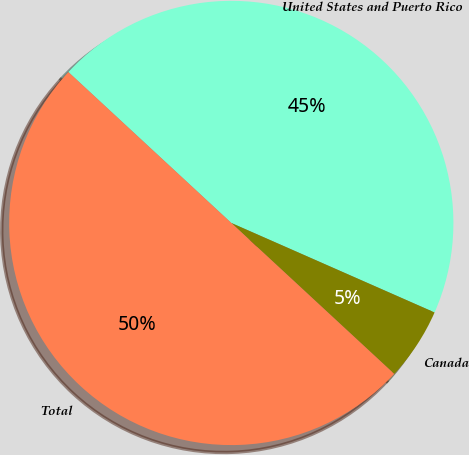Convert chart. <chart><loc_0><loc_0><loc_500><loc_500><pie_chart><fcel>United States and Puerto Rico<fcel>Canada<fcel>Total<nl><fcel>44.71%<fcel>5.29%<fcel>50.0%<nl></chart> 